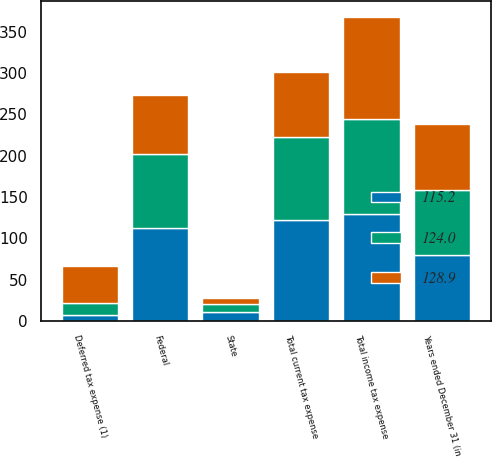Convert chart to OTSL. <chart><loc_0><loc_0><loc_500><loc_500><stacked_bar_chart><ecel><fcel>Years ended December 31 (in<fcel>Federal<fcel>State<fcel>Total current tax expense<fcel>Deferred tax expense (1)<fcel>Total income tax expense<nl><fcel>115.2<fcel>79.2<fcel>111.9<fcel>10.3<fcel>122.2<fcel>6.7<fcel>128.9<nl><fcel>124<fcel>79.2<fcel>89.9<fcel>9.8<fcel>99.7<fcel>15.5<fcel>115.2<nl><fcel>128.9<fcel>79.2<fcel>71.9<fcel>7.3<fcel>79.2<fcel>44.8<fcel>124<nl></chart> 